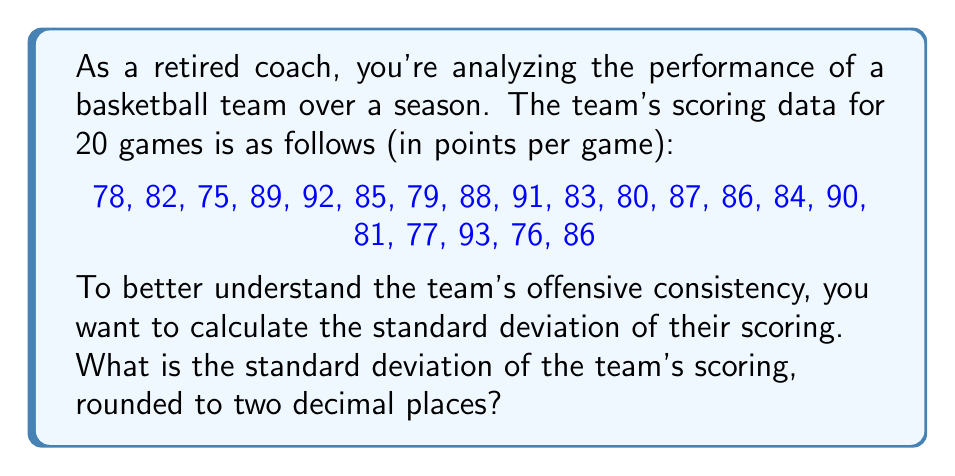What is the answer to this math problem? To calculate the standard deviation, we'll follow these steps:

1. Calculate the mean (average) score:
   $$\bar{x} = \frac{\sum_{i=1}^{n} x_i}{n}$$
   where $x_i$ are the individual scores and $n$ is the number of games.

   $$\bar{x} = \frac{78 + 82 + 75 + ... + 76 + 86}{20} = \frac{1682}{20} = 84.1$$

2. Calculate the squared differences from the mean:
   $$(x_i - \bar{x})^2$$

3. Sum the squared differences:
   $$\sum_{i=1}^{n} (x_i - \bar{x})^2$$

4. Divide by $(n-1)$ to get the variance:
   $$s^2 = \frac{\sum_{i=1}^{n} (x_i - \bar{x})^2}{n-1}$$

5. Take the square root of the variance to get the standard deviation:
   $$s = \sqrt{\frac{\sum_{i=1}^{n} (x_i - \bar{x})^2}{n-1}}$$

Calculating the squared differences and summing them:

$$(78 - 84.1)^2 + (82 - 84.1)^2 + ... + (76 - 84.1)^2 + (86 - 84.1)^2 = 1058.18$$

Now, we can plug this into our standard deviation formula:

$$s = \sqrt{\frac{1058.18}{20-1}} = \sqrt{\frac{1058.18}{19}} = \sqrt{55.69} \approx 7.46$$

Rounding to two decimal places, we get 7.46.
Answer: 7.46 